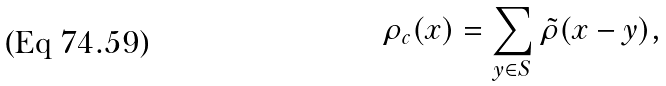Convert formula to latex. <formula><loc_0><loc_0><loc_500><loc_500>\rho _ { c } ( x ) = \sum _ { y \in S } \tilde { \rho } ( x - y ) ,</formula> 